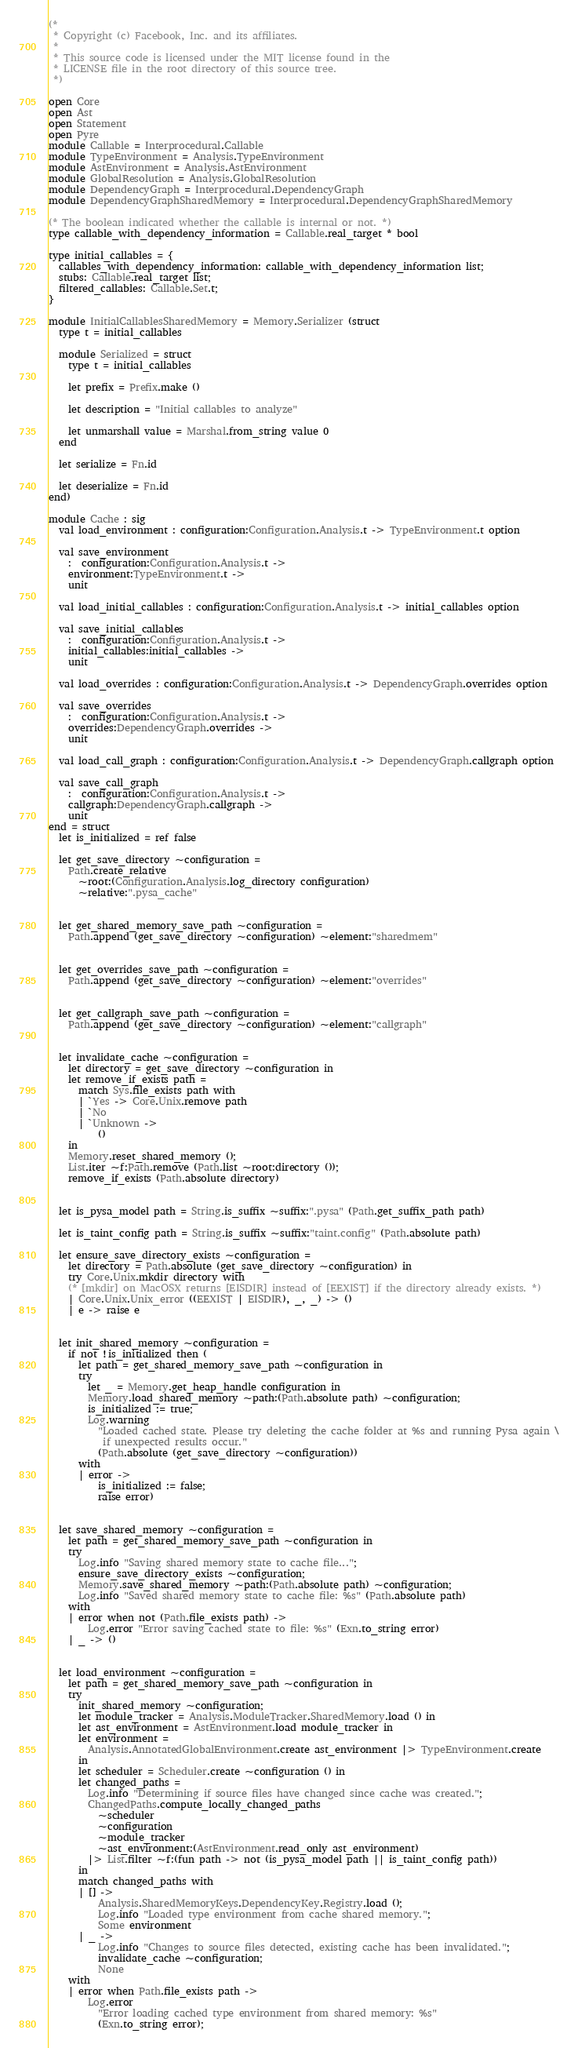<code> <loc_0><loc_0><loc_500><loc_500><_OCaml_>(*
 * Copyright (c) Facebook, Inc. and its affiliates.
 *
 * This source code is licensed under the MIT license found in the
 * LICENSE file in the root directory of this source tree.
 *)

open Core
open Ast
open Statement
open Pyre
module Callable = Interprocedural.Callable
module TypeEnvironment = Analysis.TypeEnvironment
module AstEnvironment = Analysis.AstEnvironment
module GlobalResolution = Analysis.GlobalResolution
module DependencyGraph = Interprocedural.DependencyGraph
module DependencyGraphSharedMemory = Interprocedural.DependencyGraphSharedMemory

(* The boolean indicated whether the callable is internal or not. *)
type callable_with_dependency_information = Callable.real_target * bool

type initial_callables = {
  callables_with_dependency_information: callable_with_dependency_information list;
  stubs: Callable.real_target list;
  filtered_callables: Callable.Set.t;
}

module InitialCallablesSharedMemory = Memory.Serializer (struct
  type t = initial_callables

  module Serialized = struct
    type t = initial_callables

    let prefix = Prefix.make ()

    let description = "Initial callables to analyze"

    let unmarshall value = Marshal.from_string value 0
  end

  let serialize = Fn.id

  let deserialize = Fn.id
end)

module Cache : sig
  val load_environment : configuration:Configuration.Analysis.t -> TypeEnvironment.t option

  val save_environment
    :  configuration:Configuration.Analysis.t ->
    environment:TypeEnvironment.t ->
    unit

  val load_initial_callables : configuration:Configuration.Analysis.t -> initial_callables option

  val save_initial_callables
    :  configuration:Configuration.Analysis.t ->
    initial_callables:initial_callables ->
    unit

  val load_overrides : configuration:Configuration.Analysis.t -> DependencyGraph.overrides option

  val save_overrides
    :  configuration:Configuration.Analysis.t ->
    overrides:DependencyGraph.overrides ->
    unit

  val load_call_graph : configuration:Configuration.Analysis.t -> DependencyGraph.callgraph option

  val save_call_graph
    :  configuration:Configuration.Analysis.t ->
    callgraph:DependencyGraph.callgraph ->
    unit
end = struct
  let is_initialized = ref false

  let get_save_directory ~configuration =
    Path.create_relative
      ~root:(Configuration.Analysis.log_directory configuration)
      ~relative:".pysa_cache"


  let get_shared_memory_save_path ~configuration =
    Path.append (get_save_directory ~configuration) ~element:"sharedmem"


  let get_overrides_save_path ~configuration =
    Path.append (get_save_directory ~configuration) ~element:"overrides"


  let get_callgraph_save_path ~configuration =
    Path.append (get_save_directory ~configuration) ~element:"callgraph"


  let invalidate_cache ~configuration =
    let directory = get_save_directory ~configuration in
    let remove_if_exists path =
      match Sys.file_exists path with
      | `Yes -> Core.Unix.remove path
      | `No
      | `Unknown ->
          ()
    in
    Memory.reset_shared_memory ();
    List.iter ~f:Path.remove (Path.list ~root:directory ());
    remove_if_exists (Path.absolute directory)


  let is_pysa_model path = String.is_suffix ~suffix:".pysa" (Path.get_suffix_path path)

  let is_taint_config path = String.is_suffix ~suffix:"taint.config" (Path.absolute path)

  let ensure_save_directory_exists ~configuration =
    let directory = Path.absolute (get_save_directory ~configuration) in
    try Core.Unix.mkdir directory with
    (* [mkdir] on MacOSX returns [EISDIR] instead of [EEXIST] if the directory already exists. *)
    | Core.Unix.Unix_error ((EEXIST | EISDIR), _, _) -> ()
    | e -> raise e


  let init_shared_memory ~configuration =
    if not !is_initialized then (
      let path = get_shared_memory_save_path ~configuration in
      try
        let _ = Memory.get_heap_handle configuration in
        Memory.load_shared_memory ~path:(Path.absolute path) ~configuration;
        is_initialized := true;
        Log.warning
          "Loaded cached state. Please try deleting the cache folder at %s and running Pysa again \
           if unexpected results occur."
          (Path.absolute (get_save_directory ~configuration))
      with
      | error ->
          is_initialized := false;
          raise error)


  let save_shared_memory ~configuration =
    let path = get_shared_memory_save_path ~configuration in
    try
      Log.info "Saving shared memory state to cache file...";
      ensure_save_directory_exists ~configuration;
      Memory.save_shared_memory ~path:(Path.absolute path) ~configuration;
      Log.info "Saved shared memory state to cache file: %s" (Path.absolute path)
    with
    | error when not (Path.file_exists path) ->
        Log.error "Error saving cached state to file: %s" (Exn.to_string error)
    | _ -> ()


  let load_environment ~configuration =
    let path = get_shared_memory_save_path ~configuration in
    try
      init_shared_memory ~configuration;
      let module_tracker = Analysis.ModuleTracker.SharedMemory.load () in
      let ast_environment = AstEnvironment.load module_tracker in
      let environment =
        Analysis.AnnotatedGlobalEnvironment.create ast_environment |> TypeEnvironment.create
      in
      let scheduler = Scheduler.create ~configuration () in
      let changed_paths =
        Log.info "Determining if source files have changed since cache was created.";
        ChangedPaths.compute_locally_changed_paths
          ~scheduler
          ~configuration
          ~module_tracker
          ~ast_environment:(AstEnvironment.read_only ast_environment)
        |> List.filter ~f:(fun path -> not (is_pysa_model path || is_taint_config path))
      in
      match changed_paths with
      | [] ->
          Analysis.SharedMemoryKeys.DependencyKey.Registry.load ();
          Log.info "Loaded type environment from cache shared memory.";
          Some environment
      | _ ->
          Log.info "Changes to source files detected, existing cache has been invalidated.";
          invalidate_cache ~configuration;
          None
    with
    | error when Path.file_exists path ->
        Log.error
          "Error loading cached type environment from shared memory: %s"
          (Exn.to_string error);</code> 